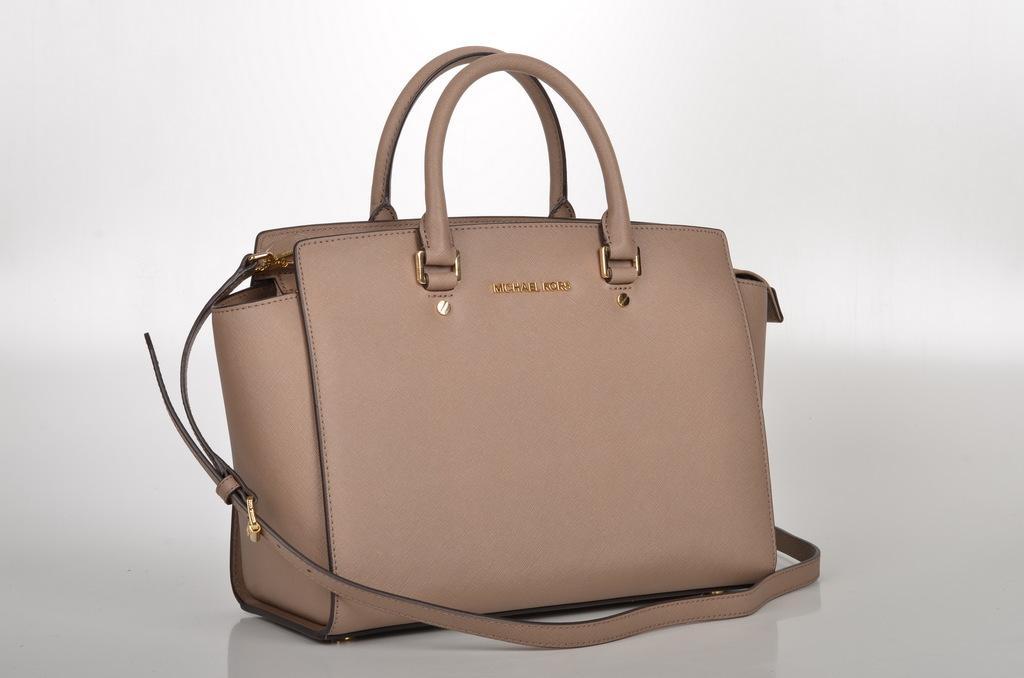Can you describe this image briefly? In this image I can see a handbag. 